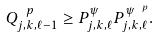<formula> <loc_0><loc_0><loc_500><loc_500>Q ^ { \ p } _ { j , k , \ell - 1 } \geq P ^ { \psi } _ { j , k , \ell } P ^ { \psi ^ { \ p } } _ { j , k , \ell } .</formula> 